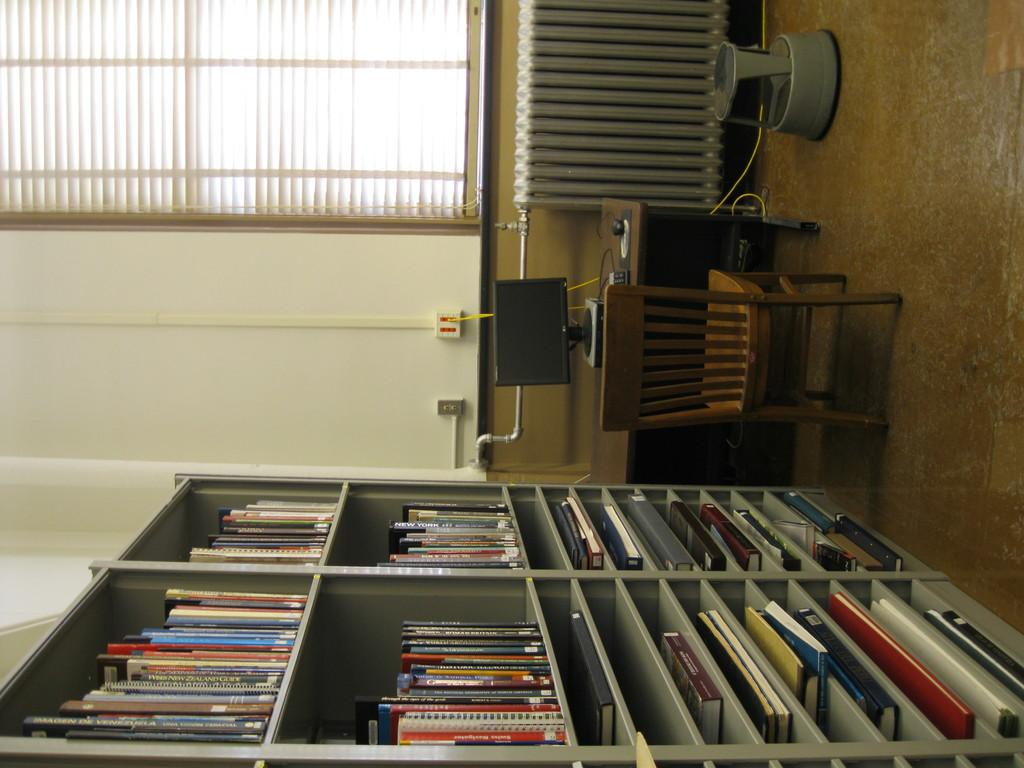What type of furniture is present in the image? There is a chair and a table in the image. What is placed on the table? There is a system on the table. What can be seen on the shelves in the image? There are books on the shelves. What part of the room is visible in the image? The floor is visible in the image. What architectural feature is present in the image? There is a window in the image. What type of window treatment is present in the image? Window blinds are present in the image. What type of flowers can be seen growing on the grass in the image? There are no flowers or grass present in the image; it features a chair, table, system, shelves, books, floor, window, and window blinds. 